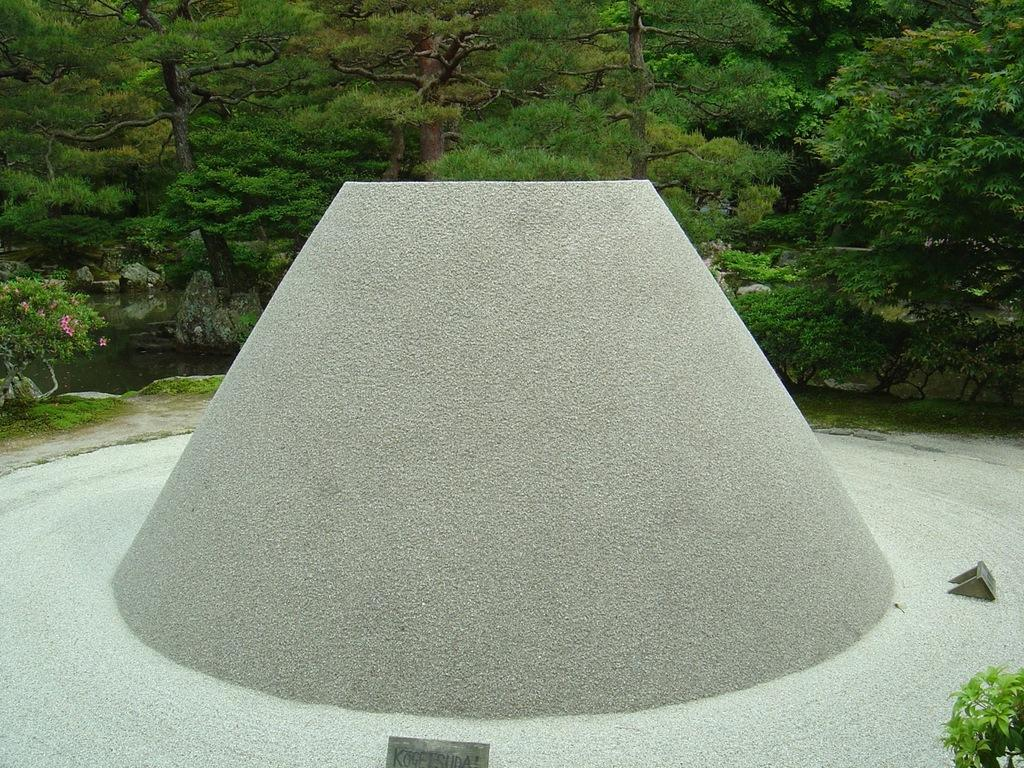What is the main object in the image? There is a sundial in the image. What can be seen in the background of the image? There are trees in the background of the image. How many jellyfish are swimming in the image? There are no jellyfish present in the image; it features a sundial and trees in the background. 